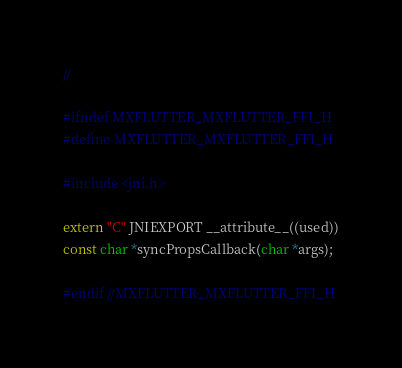Convert code to text. <code><loc_0><loc_0><loc_500><loc_500><_C_>//

#ifndef MXFLUTTER_MXFLUTTER_FFI_H
#define MXFLUTTER_MXFLUTTER_FFI_H

#include <jni.h>

extern "C" JNIEXPORT __attribute__((used))
const char *syncPropsCallback(char *args);

#endif //MXFLUTTER_MXFLUTTER_FFI_H
</code> 